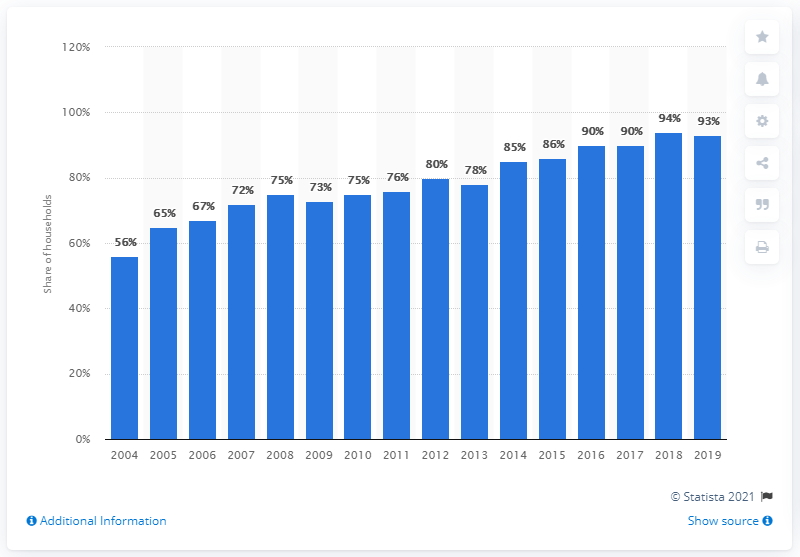Point out several critical features in this image. In 2015, approximately 86% of households in Quebec had access to the internet. 